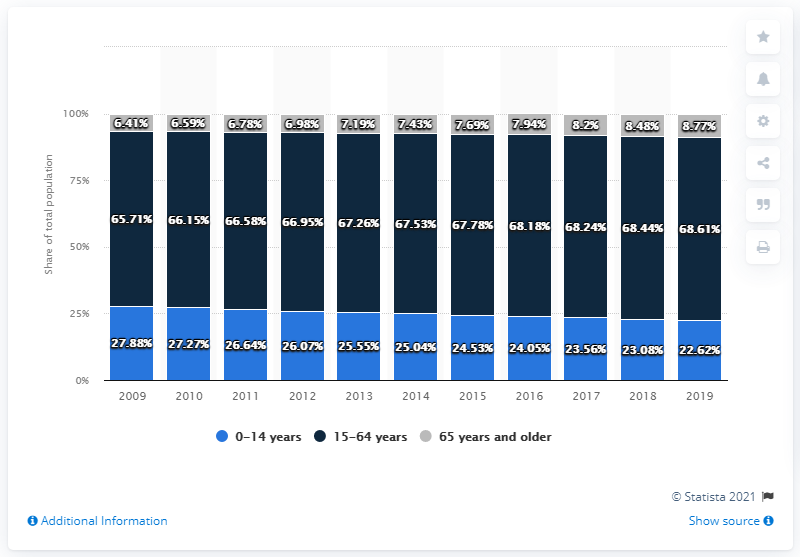Draw attention to some important aspects in this diagram. The highest percentage in the black bar is 68.51%. In 2019, the value of 5.26 is higher than in 2009. 